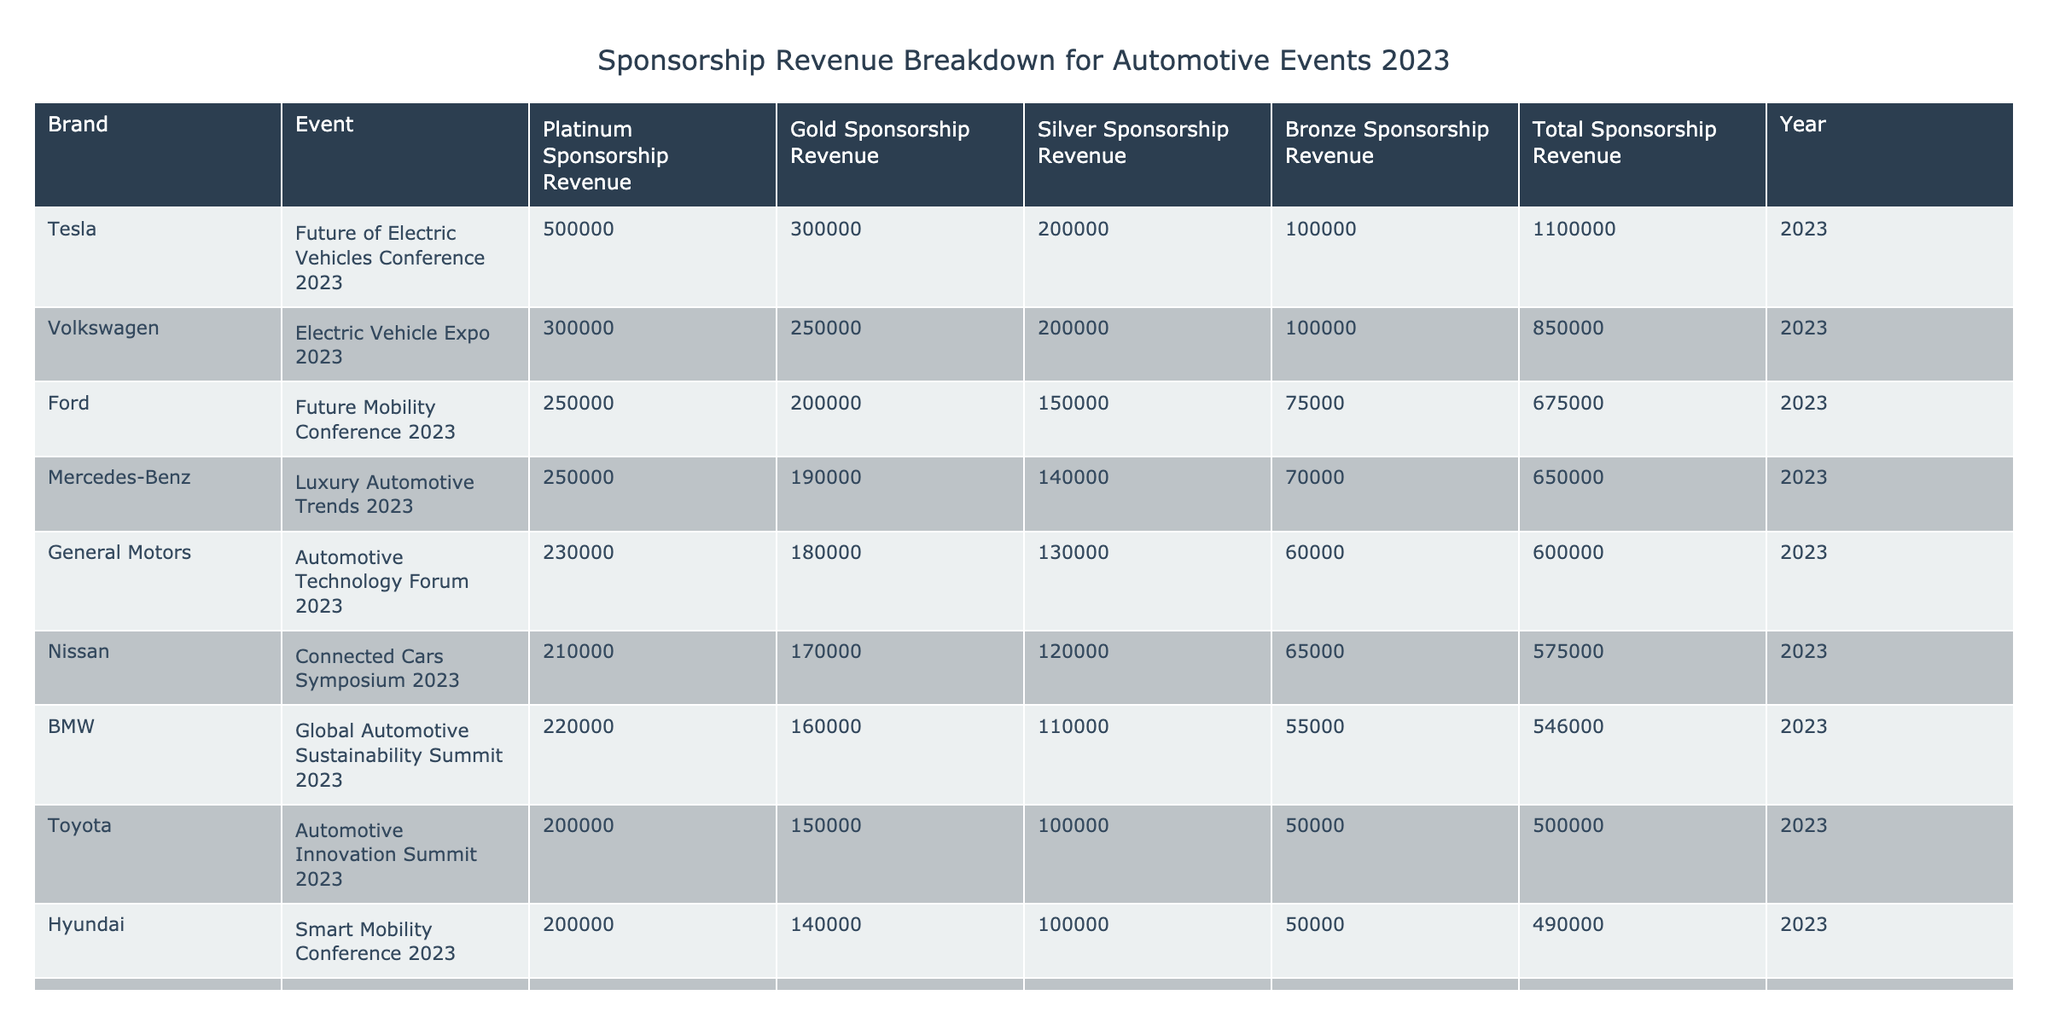What is the total sponsorship revenue generated by Tesla? The table lists Tesla's total sponsorship revenue under the column labeled "Total Sponsorship Revenue." It shows a value of 1,100,000.
Answer: 1,100,000 Which brand had the highest revenue from Platinum sponsorship? By scanning the "Platinum Sponsorship Revenue" column, Volkswagen shows the highest value at 300,000 among all brands.
Answer: Volkswagen How much more revenue did Ford generate from Gold sponsorship compared to Honda? Ford's Gold sponsorship revenue is 200,000, and Honda's is 120,000. The difference is calculated as 200,000 - 120,000 = 80,000.
Answer: 80,000 What is the average total sponsorship revenue across all brands? First, sum the total revenue for each brand, which is (500,000 + 675,000 + 850,000 + 600,000 + 405,000 + 546,000 + 650,000 + 490,000 + 575,000 + 1,100,000) = 5,291,000. Since there are 10 brands, dividing gives 5,291,000 / 10 = 529,100.
Answer: 529,100 Did any brand contribute less than 400,000 in total sponsorship revenue? By examining the "Total Sponsorship Revenue" column, both Honda (405,000) and Toyota (500,000) are more than 400,000, while Nissan (575,000) is also above this threshold. Thus, no brands contributed less than 400,000.
Answer: No Which event generated the highest total sponsorship revenue? Looking at the "Event" associated with the highest "Total Sponsorship Revenue" in the table, "Future of Electric Vehicles Conference 2023" organized by Tesla has the highest total of 1,100,000.
Answer: Future of Electric Vehicles Conference 2023 What is the total sponsorship revenue from all Gold sponsors combined? To find the total from Gold sponsorships, we sum the Gold revenue from each brand: (150,000 + 200,000 + 250,000 + 180,000 + 120,000 + 160,000 + 190,000 + 140,000 + 170,000 + 300,000) = 1,800,000.
Answer: 1,800,000 How does the total sponsorship revenue of General Motors compare to that of BMW? General Motors has a total revenue of 600,000, while BMW has 546,000. The difference is computed as 600,000 - 546,000 = 54,000. Thus, GM has more revenue by 54,000.
Answer: General Motors has 54,000 more Which brand or event received the least amount from Silver sponsorship? Scanning the "Silver Sponsorship Revenue" column, Honda shows the least revenue at 90,000.
Answer: Honda If we combine the Platinum sponsorship revenues from Toyota and Hyundai, what is the total? The Platinum revenues for both brands are 200,000 (Toyota) and 200,000 (Hyundai). Adding these gives 200,000 + 200,000 = 400,000.
Answer: 400,000 